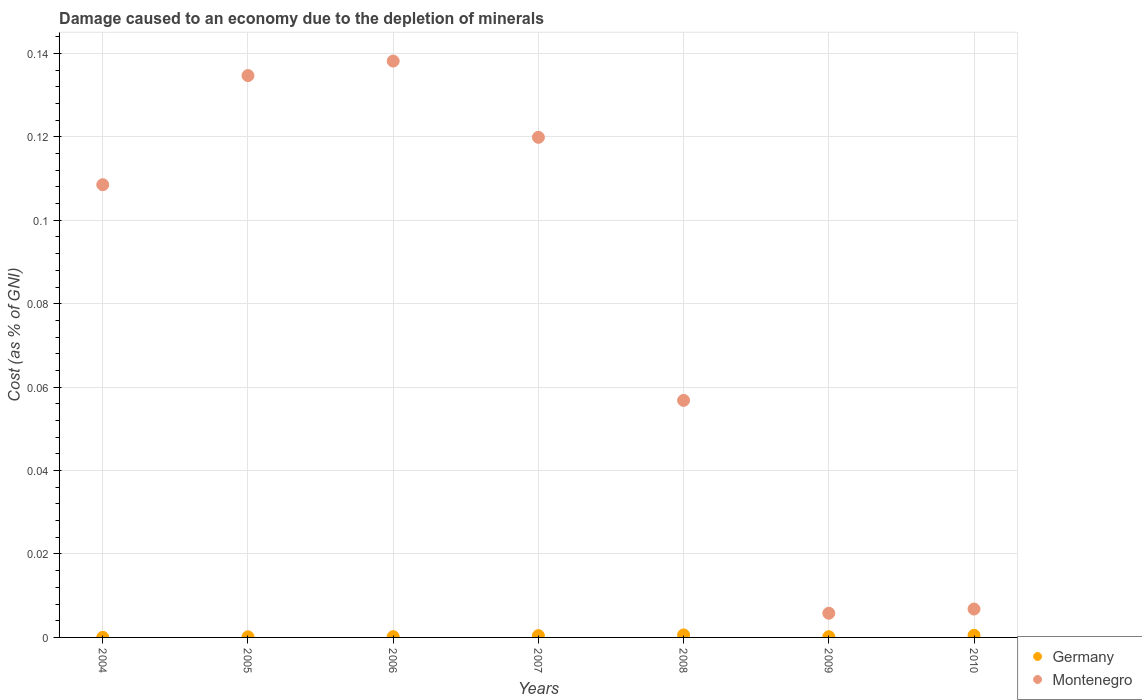How many different coloured dotlines are there?
Your answer should be compact. 2. What is the cost of damage caused due to the depletion of minerals in Germany in 2005?
Provide a succinct answer. 0. Across all years, what is the maximum cost of damage caused due to the depletion of minerals in Montenegro?
Keep it short and to the point. 0.14. Across all years, what is the minimum cost of damage caused due to the depletion of minerals in Germany?
Give a very brief answer. 1.927439780620161e-5. In which year was the cost of damage caused due to the depletion of minerals in Germany maximum?
Your response must be concise. 2008. What is the total cost of damage caused due to the depletion of minerals in Germany in the graph?
Ensure brevity in your answer.  0. What is the difference between the cost of damage caused due to the depletion of minerals in Montenegro in 2004 and that in 2006?
Provide a short and direct response. -0.03. What is the difference between the cost of damage caused due to the depletion of minerals in Germany in 2010 and the cost of damage caused due to the depletion of minerals in Montenegro in 2007?
Your response must be concise. -0.12. What is the average cost of damage caused due to the depletion of minerals in Montenegro per year?
Your answer should be very brief. 0.08. In the year 2006, what is the difference between the cost of damage caused due to the depletion of minerals in Germany and cost of damage caused due to the depletion of minerals in Montenegro?
Offer a very short reply. -0.14. What is the ratio of the cost of damage caused due to the depletion of minerals in Montenegro in 2008 to that in 2009?
Provide a succinct answer. 9.8. Is the cost of damage caused due to the depletion of minerals in Germany in 2006 less than that in 2008?
Keep it short and to the point. Yes. What is the difference between the highest and the second highest cost of damage caused due to the depletion of minerals in Germany?
Make the answer very short. 8.3913625962583e-5. What is the difference between the highest and the lowest cost of damage caused due to the depletion of minerals in Germany?
Your answer should be compact. 0. Is the sum of the cost of damage caused due to the depletion of minerals in Germany in 2008 and 2009 greater than the maximum cost of damage caused due to the depletion of minerals in Montenegro across all years?
Offer a very short reply. No. How many dotlines are there?
Keep it short and to the point. 2. How many years are there in the graph?
Ensure brevity in your answer.  7. Are the values on the major ticks of Y-axis written in scientific E-notation?
Provide a short and direct response. No. Does the graph contain any zero values?
Your answer should be very brief. No. Does the graph contain grids?
Keep it short and to the point. Yes. How many legend labels are there?
Your answer should be compact. 2. What is the title of the graph?
Provide a succinct answer. Damage caused to an economy due to the depletion of minerals. Does "Malawi" appear as one of the legend labels in the graph?
Keep it short and to the point. No. What is the label or title of the Y-axis?
Give a very brief answer. Cost (as % of GNI). What is the Cost (as % of GNI) of Germany in 2004?
Offer a terse response. 1.927439780620161e-5. What is the Cost (as % of GNI) of Montenegro in 2004?
Your answer should be very brief. 0.11. What is the Cost (as % of GNI) of Germany in 2005?
Offer a very short reply. 0. What is the Cost (as % of GNI) in Montenegro in 2005?
Your answer should be very brief. 0.13. What is the Cost (as % of GNI) in Germany in 2006?
Offer a terse response. 0. What is the Cost (as % of GNI) of Montenegro in 2006?
Ensure brevity in your answer.  0.14. What is the Cost (as % of GNI) of Germany in 2007?
Ensure brevity in your answer.  0. What is the Cost (as % of GNI) of Montenegro in 2007?
Offer a terse response. 0.12. What is the Cost (as % of GNI) in Germany in 2008?
Offer a very short reply. 0. What is the Cost (as % of GNI) of Montenegro in 2008?
Your response must be concise. 0.06. What is the Cost (as % of GNI) of Germany in 2009?
Your answer should be very brief. 0. What is the Cost (as % of GNI) of Montenegro in 2009?
Ensure brevity in your answer.  0.01. What is the Cost (as % of GNI) of Germany in 2010?
Provide a succinct answer. 0. What is the Cost (as % of GNI) in Montenegro in 2010?
Keep it short and to the point. 0.01. Across all years, what is the maximum Cost (as % of GNI) of Germany?
Offer a very short reply. 0. Across all years, what is the maximum Cost (as % of GNI) in Montenegro?
Your answer should be very brief. 0.14. Across all years, what is the minimum Cost (as % of GNI) in Germany?
Offer a very short reply. 1.927439780620161e-5. Across all years, what is the minimum Cost (as % of GNI) of Montenegro?
Keep it short and to the point. 0.01. What is the total Cost (as % of GNI) of Germany in the graph?
Offer a terse response. 0. What is the total Cost (as % of GNI) in Montenegro in the graph?
Provide a succinct answer. 0.57. What is the difference between the Cost (as % of GNI) in Germany in 2004 and that in 2005?
Keep it short and to the point. -0. What is the difference between the Cost (as % of GNI) of Montenegro in 2004 and that in 2005?
Provide a succinct answer. -0.03. What is the difference between the Cost (as % of GNI) of Germany in 2004 and that in 2006?
Provide a short and direct response. -0. What is the difference between the Cost (as % of GNI) in Montenegro in 2004 and that in 2006?
Offer a very short reply. -0.03. What is the difference between the Cost (as % of GNI) in Germany in 2004 and that in 2007?
Offer a terse response. -0. What is the difference between the Cost (as % of GNI) of Montenegro in 2004 and that in 2007?
Your answer should be very brief. -0.01. What is the difference between the Cost (as % of GNI) of Germany in 2004 and that in 2008?
Give a very brief answer. -0. What is the difference between the Cost (as % of GNI) in Montenegro in 2004 and that in 2008?
Your answer should be very brief. 0.05. What is the difference between the Cost (as % of GNI) in Germany in 2004 and that in 2009?
Your answer should be compact. -0. What is the difference between the Cost (as % of GNI) in Montenegro in 2004 and that in 2009?
Keep it short and to the point. 0.1. What is the difference between the Cost (as % of GNI) of Germany in 2004 and that in 2010?
Offer a very short reply. -0. What is the difference between the Cost (as % of GNI) of Montenegro in 2004 and that in 2010?
Keep it short and to the point. 0.1. What is the difference between the Cost (as % of GNI) of Montenegro in 2005 and that in 2006?
Offer a terse response. -0. What is the difference between the Cost (as % of GNI) in Germany in 2005 and that in 2007?
Your answer should be very brief. -0. What is the difference between the Cost (as % of GNI) in Montenegro in 2005 and that in 2007?
Provide a short and direct response. 0.01. What is the difference between the Cost (as % of GNI) of Germany in 2005 and that in 2008?
Keep it short and to the point. -0. What is the difference between the Cost (as % of GNI) in Montenegro in 2005 and that in 2008?
Provide a succinct answer. 0.08. What is the difference between the Cost (as % of GNI) in Germany in 2005 and that in 2009?
Your answer should be compact. -0. What is the difference between the Cost (as % of GNI) of Montenegro in 2005 and that in 2009?
Your answer should be very brief. 0.13. What is the difference between the Cost (as % of GNI) of Germany in 2005 and that in 2010?
Your answer should be compact. -0. What is the difference between the Cost (as % of GNI) in Montenegro in 2005 and that in 2010?
Offer a very short reply. 0.13. What is the difference between the Cost (as % of GNI) of Germany in 2006 and that in 2007?
Provide a succinct answer. -0. What is the difference between the Cost (as % of GNI) of Montenegro in 2006 and that in 2007?
Offer a terse response. 0.02. What is the difference between the Cost (as % of GNI) in Germany in 2006 and that in 2008?
Offer a terse response. -0. What is the difference between the Cost (as % of GNI) of Montenegro in 2006 and that in 2008?
Offer a very short reply. 0.08. What is the difference between the Cost (as % of GNI) of Montenegro in 2006 and that in 2009?
Your answer should be compact. 0.13. What is the difference between the Cost (as % of GNI) in Germany in 2006 and that in 2010?
Your answer should be very brief. -0. What is the difference between the Cost (as % of GNI) of Montenegro in 2006 and that in 2010?
Give a very brief answer. 0.13. What is the difference between the Cost (as % of GNI) of Germany in 2007 and that in 2008?
Keep it short and to the point. -0. What is the difference between the Cost (as % of GNI) of Montenegro in 2007 and that in 2008?
Your answer should be compact. 0.06. What is the difference between the Cost (as % of GNI) of Germany in 2007 and that in 2009?
Keep it short and to the point. 0. What is the difference between the Cost (as % of GNI) of Montenegro in 2007 and that in 2009?
Ensure brevity in your answer.  0.11. What is the difference between the Cost (as % of GNI) of Germany in 2007 and that in 2010?
Offer a terse response. -0. What is the difference between the Cost (as % of GNI) of Montenegro in 2007 and that in 2010?
Your answer should be very brief. 0.11. What is the difference between the Cost (as % of GNI) of Montenegro in 2008 and that in 2009?
Your response must be concise. 0.05. What is the difference between the Cost (as % of GNI) of Germany in 2008 and that in 2010?
Offer a very short reply. 0. What is the difference between the Cost (as % of GNI) of Montenegro in 2008 and that in 2010?
Keep it short and to the point. 0.05. What is the difference between the Cost (as % of GNI) in Germany in 2009 and that in 2010?
Keep it short and to the point. -0. What is the difference between the Cost (as % of GNI) in Montenegro in 2009 and that in 2010?
Provide a succinct answer. -0. What is the difference between the Cost (as % of GNI) of Germany in 2004 and the Cost (as % of GNI) of Montenegro in 2005?
Provide a short and direct response. -0.13. What is the difference between the Cost (as % of GNI) in Germany in 2004 and the Cost (as % of GNI) in Montenegro in 2006?
Your answer should be very brief. -0.14. What is the difference between the Cost (as % of GNI) of Germany in 2004 and the Cost (as % of GNI) of Montenegro in 2007?
Offer a very short reply. -0.12. What is the difference between the Cost (as % of GNI) in Germany in 2004 and the Cost (as % of GNI) in Montenegro in 2008?
Give a very brief answer. -0.06. What is the difference between the Cost (as % of GNI) in Germany in 2004 and the Cost (as % of GNI) in Montenegro in 2009?
Ensure brevity in your answer.  -0.01. What is the difference between the Cost (as % of GNI) of Germany in 2004 and the Cost (as % of GNI) of Montenegro in 2010?
Offer a terse response. -0.01. What is the difference between the Cost (as % of GNI) in Germany in 2005 and the Cost (as % of GNI) in Montenegro in 2006?
Ensure brevity in your answer.  -0.14. What is the difference between the Cost (as % of GNI) of Germany in 2005 and the Cost (as % of GNI) of Montenegro in 2007?
Offer a very short reply. -0.12. What is the difference between the Cost (as % of GNI) of Germany in 2005 and the Cost (as % of GNI) of Montenegro in 2008?
Your answer should be compact. -0.06. What is the difference between the Cost (as % of GNI) in Germany in 2005 and the Cost (as % of GNI) in Montenegro in 2009?
Your answer should be compact. -0.01. What is the difference between the Cost (as % of GNI) of Germany in 2005 and the Cost (as % of GNI) of Montenegro in 2010?
Keep it short and to the point. -0.01. What is the difference between the Cost (as % of GNI) in Germany in 2006 and the Cost (as % of GNI) in Montenegro in 2007?
Provide a short and direct response. -0.12. What is the difference between the Cost (as % of GNI) of Germany in 2006 and the Cost (as % of GNI) of Montenegro in 2008?
Give a very brief answer. -0.06. What is the difference between the Cost (as % of GNI) in Germany in 2006 and the Cost (as % of GNI) in Montenegro in 2009?
Ensure brevity in your answer.  -0.01. What is the difference between the Cost (as % of GNI) in Germany in 2006 and the Cost (as % of GNI) in Montenegro in 2010?
Provide a short and direct response. -0.01. What is the difference between the Cost (as % of GNI) in Germany in 2007 and the Cost (as % of GNI) in Montenegro in 2008?
Offer a terse response. -0.06. What is the difference between the Cost (as % of GNI) in Germany in 2007 and the Cost (as % of GNI) in Montenegro in 2009?
Make the answer very short. -0.01. What is the difference between the Cost (as % of GNI) of Germany in 2007 and the Cost (as % of GNI) of Montenegro in 2010?
Ensure brevity in your answer.  -0.01. What is the difference between the Cost (as % of GNI) of Germany in 2008 and the Cost (as % of GNI) of Montenegro in 2009?
Provide a succinct answer. -0.01. What is the difference between the Cost (as % of GNI) of Germany in 2008 and the Cost (as % of GNI) of Montenegro in 2010?
Ensure brevity in your answer.  -0.01. What is the difference between the Cost (as % of GNI) in Germany in 2009 and the Cost (as % of GNI) in Montenegro in 2010?
Make the answer very short. -0.01. What is the average Cost (as % of GNI) in Germany per year?
Provide a succinct answer. 0. What is the average Cost (as % of GNI) in Montenegro per year?
Offer a terse response. 0.08. In the year 2004, what is the difference between the Cost (as % of GNI) of Germany and Cost (as % of GNI) of Montenegro?
Your answer should be very brief. -0.11. In the year 2005, what is the difference between the Cost (as % of GNI) in Germany and Cost (as % of GNI) in Montenegro?
Your answer should be very brief. -0.13. In the year 2006, what is the difference between the Cost (as % of GNI) in Germany and Cost (as % of GNI) in Montenegro?
Make the answer very short. -0.14. In the year 2007, what is the difference between the Cost (as % of GNI) of Germany and Cost (as % of GNI) of Montenegro?
Offer a terse response. -0.12. In the year 2008, what is the difference between the Cost (as % of GNI) of Germany and Cost (as % of GNI) of Montenegro?
Your answer should be very brief. -0.06. In the year 2009, what is the difference between the Cost (as % of GNI) of Germany and Cost (as % of GNI) of Montenegro?
Make the answer very short. -0.01. In the year 2010, what is the difference between the Cost (as % of GNI) in Germany and Cost (as % of GNI) in Montenegro?
Provide a succinct answer. -0.01. What is the ratio of the Cost (as % of GNI) of Germany in 2004 to that in 2005?
Offer a very short reply. 0.13. What is the ratio of the Cost (as % of GNI) in Montenegro in 2004 to that in 2005?
Make the answer very short. 0.81. What is the ratio of the Cost (as % of GNI) in Germany in 2004 to that in 2006?
Give a very brief answer. 0.11. What is the ratio of the Cost (as % of GNI) of Montenegro in 2004 to that in 2006?
Make the answer very short. 0.79. What is the ratio of the Cost (as % of GNI) of Germany in 2004 to that in 2007?
Keep it short and to the point. 0.04. What is the ratio of the Cost (as % of GNI) in Montenegro in 2004 to that in 2007?
Give a very brief answer. 0.91. What is the ratio of the Cost (as % of GNI) of Germany in 2004 to that in 2008?
Make the answer very short. 0.03. What is the ratio of the Cost (as % of GNI) in Montenegro in 2004 to that in 2008?
Your answer should be very brief. 1.91. What is the ratio of the Cost (as % of GNI) of Germany in 2004 to that in 2009?
Ensure brevity in your answer.  0.11. What is the ratio of the Cost (as % of GNI) in Montenegro in 2004 to that in 2009?
Ensure brevity in your answer.  18.72. What is the ratio of the Cost (as % of GNI) in Germany in 2004 to that in 2010?
Ensure brevity in your answer.  0.04. What is the ratio of the Cost (as % of GNI) in Montenegro in 2004 to that in 2010?
Give a very brief answer. 15.94. What is the ratio of the Cost (as % of GNI) of Germany in 2005 to that in 2006?
Make the answer very short. 0.82. What is the ratio of the Cost (as % of GNI) in Montenegro in 2005 to that in 2006?
Your answer should be very brief. 0.97. What is the ratio of the Cost (as % of GNI) of Germany in 2005 to that in 2007?
Your answer should be very brief. 0.34. What is the ratio of the Cost (as % of GNI) of Montenegro in 2005 to that in 2007?
Make the answer very short. 1.12. What is the ratio of the Cost (as % of GNI) of Germany in 2005 to that in 2008?
Ensure brevity in your answer.  0.25. What is the ratio of the Cost (as % of GNI) in Montenegro in 2005 to that in 2008?
Provide a short and direct response. 2.37. What is the ratio of the Cost (as % of GNI) in Germany in 2005 to that in 2009?
Provide a succinct answer. 0.85. What is the ratio of the Cost (as % of GNI) in Montenegro in 2005 to that in 2009?
Provide a short and direct response. 23.24. What is the ratio of the Cost (as % of GNI) in Germany in 2005 to that in 2010?
Make the answer very short. 0.29. What is the ratio of the Cost (as % of GNI) of Montenegro in 2005 to that in 2010?
Your response must be concise. 19.79. What is the ratio of the Cost (as % of GNI) of Germany in 2006 to that in 2007?
Offer a very short reply. 0.42. What is the ratio of the Cost (as % of GNI) of Montenegro in 2006 to that in 2007?
Your answer should be compact. 1.15. What is the ratio of the Cost (as % of GNI) of Germany in 2006 to that in 2008?
Your answer should be very brief. 0.31. What is the ratio of the Cost (as % of GNI) of Montenegro in 2006 to that in 2008?
Ensure brevity in your answer.  2.43. What is the ratio of the Cost (as % of GNI) in Germany in 2006 to that in 2009?
Give a very brief answer. 1.04. What is the ratio of the Cost (as % of GNI) of Montenegro in 2006 to that in 2009?
Your answer should be very brief. 23.84. What is the ratio of the Cost (as % of GNI) of Germany in 2006 to that in 2010?
Offer a terse response. 0.36. What is the ratio of the Cost (as % of GNI) of Montenegro in 2006 to that in 2010?
Offer a very short reply. 20.3. What is the ratio of the Cost (as % of GNI) of Germany in 2007 to that in 2008?
Offer a terse response. 0.74. What is the ratio of the Cost (as % of GNI) of Montenegro in 2007 to that in 2008?
Keep it short and to the point. 2.11. What is the ratio of the Cost (as % of GNI) in Germany in 2007 to that in 2009?
Keep it short and to the point. 2.5. What is the ratio of the Cost (as % of GNI) of Montenegro in 2007 to that in 2009?
Offer a terse response. 20.68. What is the ratio of the Cost (as % of GNI) in Germany in 2007 to that in 2010?
Your answer should be compact. 0.86. What is the ratio of the Cost (as % of GNI) in Montenegro in 2007 to that in 2010?
Ensure brevity in your answer.  17.61. What is the ratio of the Cost (as % of GNI) of Germany in 2008 to that in 2009?
Provide a succinct answer. 3.39. What is the ratio of the Cost (as % of GNI) in Montenegro in 2008 to that in 2009?
Your answer should be compact. 9.8. What is the ratio of the Cost (as % of GNI) of Germany in 2008 to that in 2010?
Ensure brevity in your answer.  1.16. What is the ratio of the Cost (as % of GNI) of Montenegro in 2008 to that in 2010?
Ensure brevity in your answer.  8.35. What is the ratio of the Cost (as % of GNI) in Germany in 2009 to that in 2010?
Offer a very short reply. 0.34. What is the ratio of the Cost (as % of GNI) of Montenegro in 2009 to that in 2010?
Make the answer very short. 0.85. What is the difference between the highest and the second highest Cost (as % of GNI) of Germany?
Your answer should be very brief. 0. What is the difference between the highest and the second highest Cost (as % of GNI) of Montenegro?
Make the answer very short. 0. What is the difference between the highest and the lowest Cost (as % of GNI) of Germany?
Offer a terse response. 0. What is the difference between the highest and the lowest Cost (as % of GNI) in Montenegro?
Your response must be concise. 0.13. 